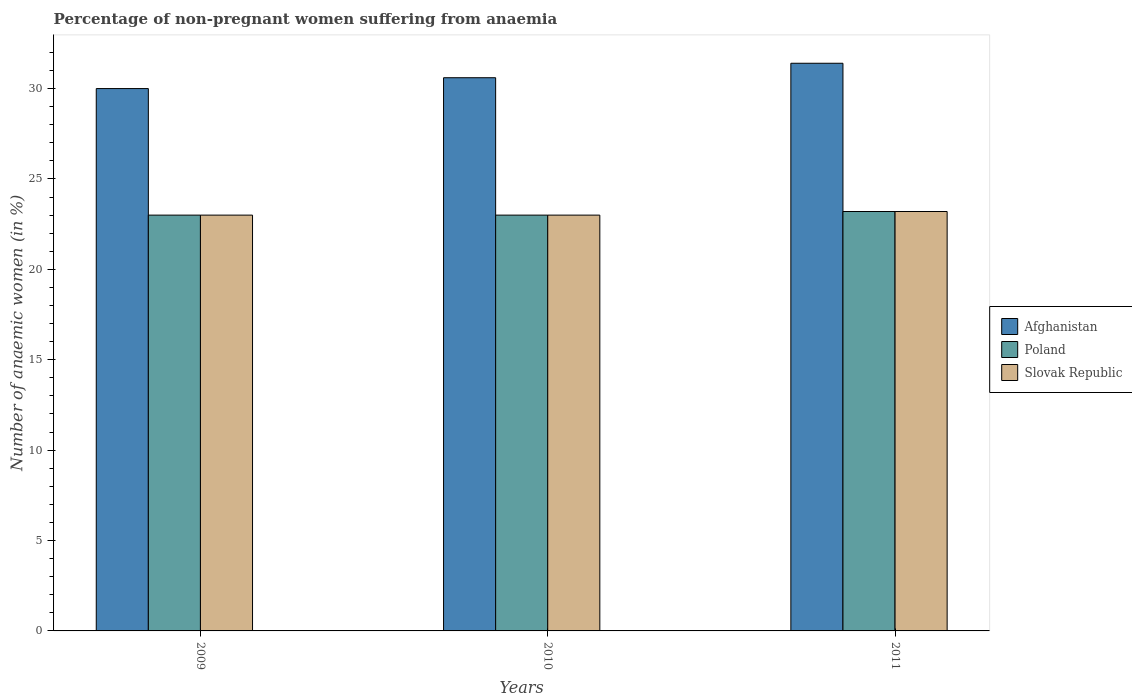Are the number of bars per tick equal to the number of legend labels?
Keep it short and to the point. Yes. Are the number of bars on each tick of the X-axis equal?
Give a very brief answer. Yes. How many bars are there on the 3rd tick from the right?
Offer a very short reply. 3. What is the label of the 3rd group of bars from the left?
Keep it short and to the point. 2011. What is the percentage of non-pregnant women suffering from anaemia in Poland in 2011?
Your response must be concise. 23.2. Across all years, what is the maximum percentage of non-pregnant women suffering from anaemia in Poland?
Ensure brevity in your answer.  23.2. What is the total percentage of non-pregnant women suffering from anaemia in Afghanistan in the graph?
Offer a very short reply. 92. What is the difference between the percentage of non-pregnant women suffering from anaemia in Afghanistan in 2010 and that in 2011?
Your answer should be compact. -0.8. What is the difference between the percentage of non-pregnant women suffering from anaemia in Slovak Republic in 2011 and the percentage of non-pregnant women suffering from anaemia in Afghanistan in 2010?
Give a very brief answer. -7.4. What is the average percentage of non-pregnant women suffering from anaemia in Afghanistan per year?
Your answer should be compact. 30.67. In the year 2009, what is the difference between the percentage of non-pregnant women suffering from anaemia in Slovak Republic and percentage of non-pregnant women suffering from anaemia in Afghanistan?
Offer a very short reply. -7. What is the ratio of the percentage of non-pregnant women suffering from anaemia in Afghanistan in 2009 to that in 2010?
Keep it short and to the point. 0.98. Is the difference between the percentage of non-pregnant women suffering from anaemia in Slovak Republic in 2010 and 2011 greater than the difference between the percentage of non-pregnant women suffering from anaemia in Afghanistan in 2010 and 2011?
Keep it short and to the point. Yes. What is the difference between the highest and the second highest percentage of non-pregnant women suffering from anaemia in Slovak Republic?
Offer a very short reply. 0.2. What is the difference between the highest and the lowest percentage of non-pregnant women suffering from anaemia in Poland?
Make the answer very short. 0.2. In how many years, is the percentage of non-pregnant women suffering from anaemia in Afghanistan greater than the average percentage of non-pregnant women suffering from anaemia in Afghanistan taken over all years?
Make the answer very short. 1. Is the sum of the percentage of non-pregnant women suffering from anaemia in Afghanistan in 2009 and 2010 greater than the maximum percentage of non-pregnant women suffering from anaemia in Poland across all years?
Give a very brief answer. Yes. What does the 1st bar from the left in 2009 represents?
Your answer should be very brief. Afghanistan. What does the 3rd bar from the right in 2010 represents?
Your response must be concise. Afghanistan. How many bars are there?
Ensure brevity in your answer.  9. Are all the bars in the graph horizontal?
Your response must be concise. No. What is the difference between two consecutive major ticks on the Y-axis?
Your answer should be compact. 5. Are the values on the major ticks of Y-axis written in scientific E-notation?
Provide a short and direct response. No. Does the graph contain any zero values?
Provide a short and direct response. No. Does the graph contain grids?
Your answer should be compact. No. How many legend labels are there?
Keep it short and to the point. 3. What is the title of the graph?
Keep it short and to the point. Percentage of non-pregnant women suffering from anaemia. What is the label or title of the Y-axis?
Your answer should be compact. Number of anaemic women (in %). What is the Number of anaemic women (in %) of Afghanistan in 2010?
Offer a very short reply. 30.6. What is the Number of anaemic women (in %) in Slovak Republic in 2010?
Provide a succinct answer. 23. What is the Number of anaemic women (in %) of Afghanistan in 2011?
Offer a terse response. 31.4. What is the Number of anaemic women (in %) of Poland in 2011?
Make the answer very short. 23.2. What is the Number of anaemic women (in %) in Slovak Republic in 2011?
Keep it short and to the point. 23.2. Across all years, what is the maximum Number of anaemic women (in %) of Afghanistan?
Provide a short and direct response. 31.4. Across all years, what is the maximum Number of anaemic women (in %) of Poland?
Ensure brevity in your answer.  23.2. Across all years, what is the maximum Number of anaemic women (in %) in Slovak Republic?
Your answer should be very brief. 23.2. Across all years, what is the minimum Number of anaemic women (in %) of Afghanistan?
Make the answer very short. 30. What is the total Number of anaemic women (in %) of Afghanistan in the graph?
Ensure brevity in your answer.  92. What is the total Number of anaemic women (in %) of Poland in the graph?
Make the answer very short. 69.2. What is the total Number of anaemic women (in %) of Slovak Republic in the graph?
Keep it short and to the point. 69.2. What is the difference between the Number of anaemic women (in %) of Afghanistan in 2009 and that in 2010?
Make the answer very short. -0.6. What is the difference between the Number of anaemic women (in %) in Slovak Republic in 2009 and that in 2010?
Make the answer very short. 0. What is the difference between the Number of anaemic women (in %) in Afghanistan in 2009 and that in 2011?
Ensure brevity in your answer.  -1.4. What is the difference between the Number of anaemic women (in %) of Poland in 2009 and that in 2011?
Your answer should be compact. -0.2. What is the difference between the Number of anaemic women (in %) in Slovak Republic in 2010 and that in 2011?
Provide a short and direct response. -0.2. What is the difference between the Number of anaemic women (in %) of Poland in 2009 and the Number of anaemic women (in %) of Slovak Republic in 2010?
Offer a very short reply. 0. What is the difference between the Number of anaemic women (in %) in Afghanistan in 2009 and the Number of anaemic women (in %) in Slovak Republic in 2011?
Make the answer very short. 6.8. What is the difference between the Number of anaemic women (in %) of Afghanistan in 2010 and the Number of anaemic women (in %) of Poland in 2011?
Offer a very short reply. 7.4. What is the difference between the Number of anaemic women (in %) of Afghanistan in 2010 and the Number of anaemic women (in %) of Slovak Republic in 2011?
Your answer should be very brief. 7.4. What is the average Number of anaemic women (in %) of Afghanistan per year?
Provide a short and direct response. 30.67. What is the average Number of anaemic women (in %) in Poland per year?
Provide a succinct answer. 23.07. What is the average Number of anaemic women (in %) of Slovak Republic per year?
Keep it short and to the point. 23.07. In the year 2009, what is the difference between the Number of anaemic women (in %) of Afghanistan and Number of anaemic women (in %) of Poland?
Provide a short and direct response. 7. In the year 2009, what is the difference between the Number of anaemic women (in %) of Afghanistan and Number of anaemic women (in %) of Slovak Republic?
Offer a terse response. 7. In the year 2009, what is the difference between the Number of anaemic women (in %) in Poland and Number of anaemic women (in %) in Slovak Republic?
Your response must be concise. 0. In the year 2010, what is the difference between the Number of anaemic women (in %) of Afghanistan and Number of anaemic women (in %) of Poland?
Make the answer very short. 7.6. In the year 2011, what is the difference between the Number of anaemic women (in %) in Afghanistan and Number of anaemic women (in %) in Poland?
Your response must be concise. 8.2. What is the ratio of the Number of anaemic women (in %) in Afghanistan in 2009 to that in 2010?
Your answer should be compact. 0.98. What is the ratio of the Number of anaemic women (in %) of Afghanistan in 2009 to that in 2011?
Provide a short and direct response. 0.96. What is the ratio of the Number of anaemic women (in %) in Poland in 2009 to that in 2011?
Your answer should be very brief. 0.99. What is the ratio of the Number of anaemic women (in %) of Slovak Republic in 2009 to that in 2011?
Offer a terse response. 0.99. What is the ratio of the Number of anaemic women (in %) in Afghanistan in 2010 to that in 2011?
Make the answer very short. 0.97. What is the ratio of the Number of anaemic women (in %) of Slovak Republic in 2010 to that in 2011?
Ensure brevity in your answer.  0.99. What is the difference between the highest and the second highest Number of anaemic women (in %) in Afghanistan?
Keep it short and to the point. 0.8. What is the difference between the highest and the lowest Number of anaemic women (in %) of Afghanistan?
Ensure brevity in your answer.  1.4. What is the difference between the highest and the lowest Number of anaemic women (in %) of Poland?
Make the answer very short. 0.2. 